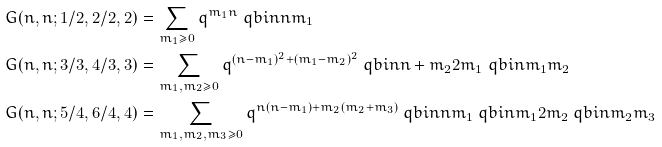<formula> <loc_0><loc_0><loc_500><loc_500>G ( n , n ; 1 / 2 , 2 / 2 , 2 ) & = \sum _ { m _ { 1 } \geq 0 } q ^ { m _ { 1 } n } \ q b i n { n } { m _ { 1 } } \\ G ( n , n ; 3 / 3 , 4 / 3 , 3 ) & = \sum _ { m _ { 1 } , m _ { 2 } \geq 0 } q ^ { ( n - m _ { 1 } ) ^ { 2 } + ( m _ { 1 } - m _ { 2 } ) ^ { 2 } } \ q b i n { n + m _ { 2 } } { 2 m _ { 1 } } \ q b i n { m _ { 1 } } { m _ { 2 } } \\ G ( n , n ; 5 / 4 , 6 / 4 , 4 ) & = \sum _ { m _ { 1 } , m _ { 2 } , m _ { 3 } \geq 0 } q ^ { n ( n - m _ { 1 } ) + m _ { 2 } ( m _ { 2 } + m _ { 3 } ) } \ q b i n { n } { m _ { 1 } } \ q b i n { m _ { 1 } } { 2 m _ { 2 } } \ q b i n { m _ { 2 } } { m _ { 3 } }</formula> 